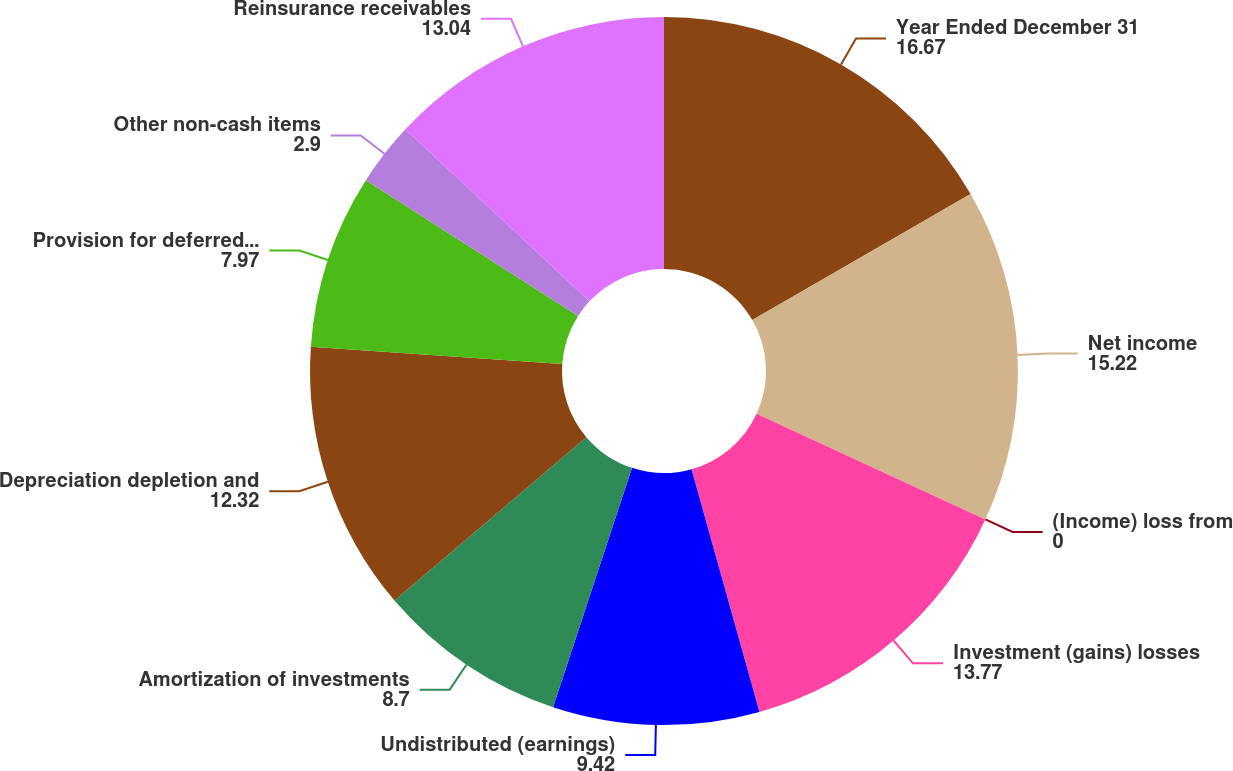<chart> <loc_0><loc_0><loc_500><loc_500><pie_chart><fcel>Year Ended December 31<fcel>Net income<fcel>(Income) loss from<fcel>Investment (gains) losses<fcel>Undistributed (earnings)<fcel>Amortization of investments<fcel>Depreciation depletion and<fcel>Provision for deferred income<fcel>Other non-cash items<fcel>Reinsurance receivables<nl><fcel>16.67%<fcel>15.22%<fcel>0.0%<fcel>13.77%<fcel>9.42%<fcel>8.7%<fcel>12.32%<fcel>7.97%<fcel>2.9%<fcel>13.04%<nl></chart> 